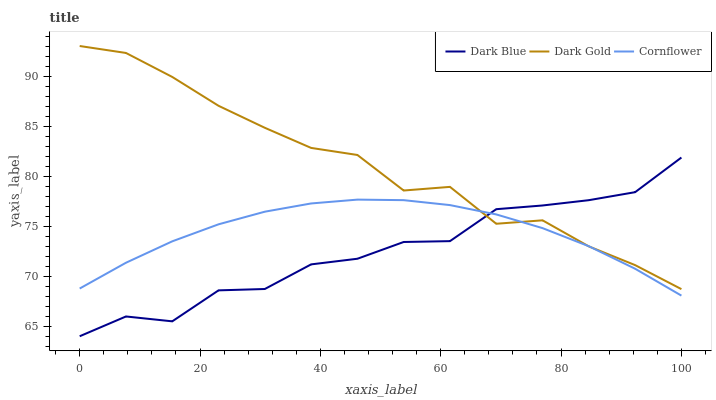Does Dark Blue have the minimum area under the curve?
Answer yes or no. Yes. Does Dark Gold have the maximum area under the curve?
Answer yes or no. Yes. Does Cornflower have the minimum area under the curve?
Answer yes or no. No. Does Cornflower have the maximum area under the curve?
Answer yes or no. No. Is Cornflower the smoothest?
Answer yes or no. Yes. Is Dark Blue the roughest?
Answer yes or no. Yes. Is Dark Gold the smoothest?
Answer yes or no. No. Is Dark Gold the roughest?
Answer yes or no. No. Does Dark Blue have the lowest value?
Answer yes or no. Yes. Does Cornflower have the lowest value?
Answer yes or no. No. Does Dark Gold have the highest value?
Answer yes or no. Yes. Does Cornflower have the highest value?
Answer yes or no. No. Does Dark Gold intersect Dark Blue?
Answer yes or no. Yes. Is Dark Gold less than Dark Blue?
Answer yes or no. No. Is Dark Gold greater than Dark Blue?
Answer yes or no. No. 